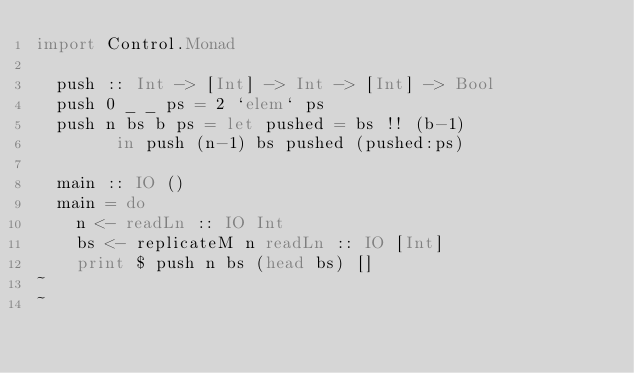Convert code to text. <code><loc_0><loc_0><loc_500><loc_500><_Haskell_>import Control.Monad 
  
  push :: Int -> [Int] -> Int -> [Int] -> Bool
  push 0 _ _ ps = 2 `elem` ps                          
  push n bs b ps = let pushed = bs !! (b-1)
        in push (n-1) bs pushed (pushed:ps)
  
  main :: IO ()
  main = do
    n <- readLn :: IO Int
    bs <- replicateM n readLn :: IO [Int]                                               
    print $ push n bs (head bs) []                                                      
~                                                                                                                                                                          
~                                          </code> 